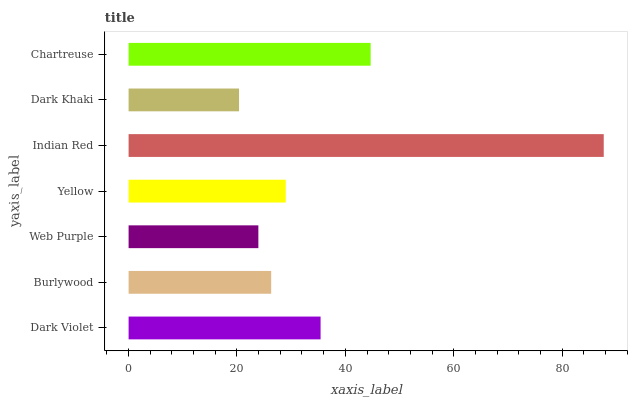Is Dark Khaki the minimum?
Answer yes or no. Yes. Is Indian Red the maximum?
Answer yes or no. Yes. Is Burlywood the minimum?
Answer yes or no. No. Is Burlywood the maximum?
Answer yes or no. No. Is Dark Violet greater than Burlywood?
Answer yes or no. Yes. Is Burlywood less than Dark Violet?
Answer yes or no. Yes. Is Burlywood greater than Dark Violet?
Answer yes or no. No. Is Dark Violet less than Burlywood?
Answer yes or no. No. Is Yellow the high median?
Answer yes or no. Yes. Is Yellow the low median?
Answer yes or no. Yes. Is Chartreuse the high median?
Answer yes or no. No. Is Dark Khaki the low median?
Answer yes or no. No. 